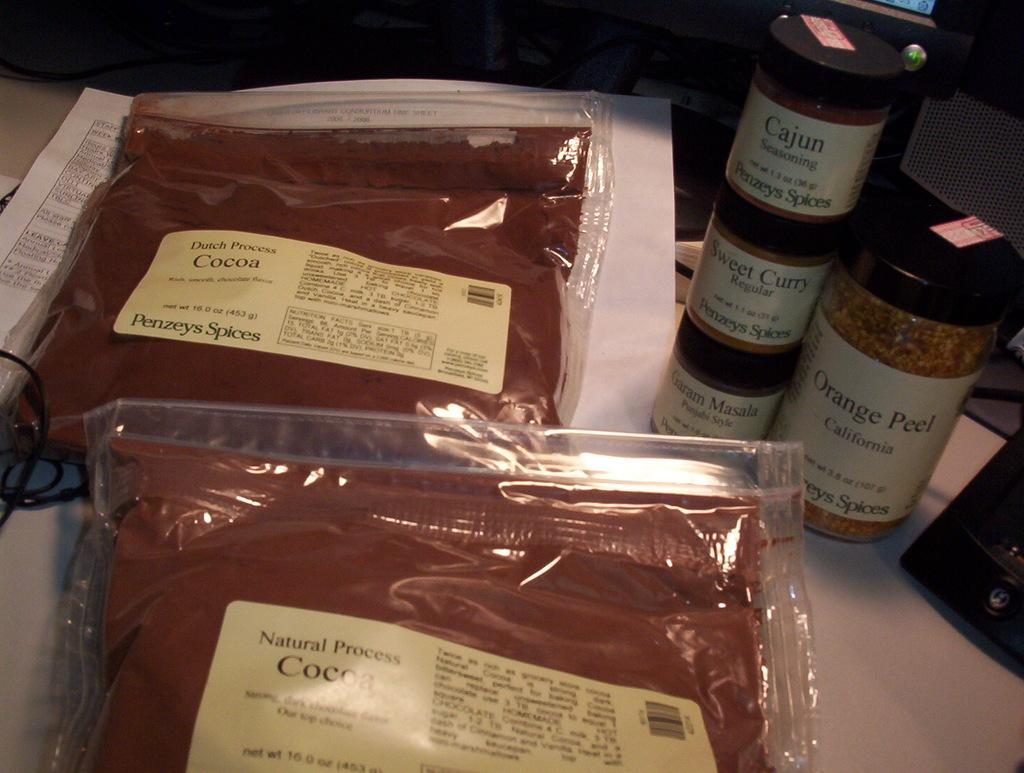<image>
Present a compact description of the photo's key features. The jar labeled "Orange Peel" sits next to three other spices and two bags of cocoa. 